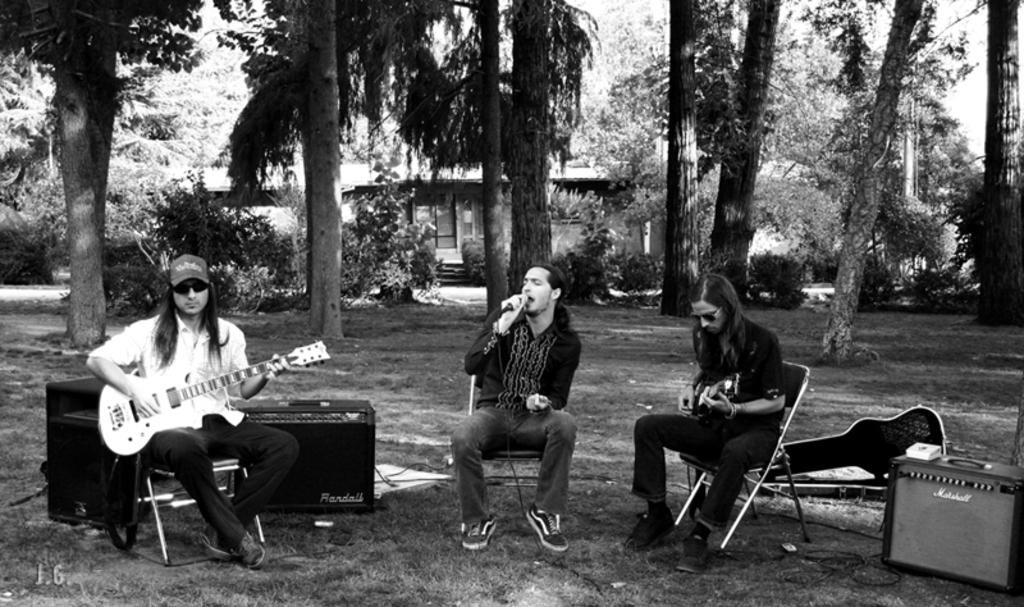How many people are in the image? There are three people in the image. What are the people doing in the image? The people are sitting on chairs and playing musical instruments. What can be seen in the background of the image? Trees and the sky are visible in the background of the image. What flavor of cracker is being passed around during the voyage in the image? There is no voyage or cracker present in the image; it features three people playing musical instruments while sitting on chairs. 